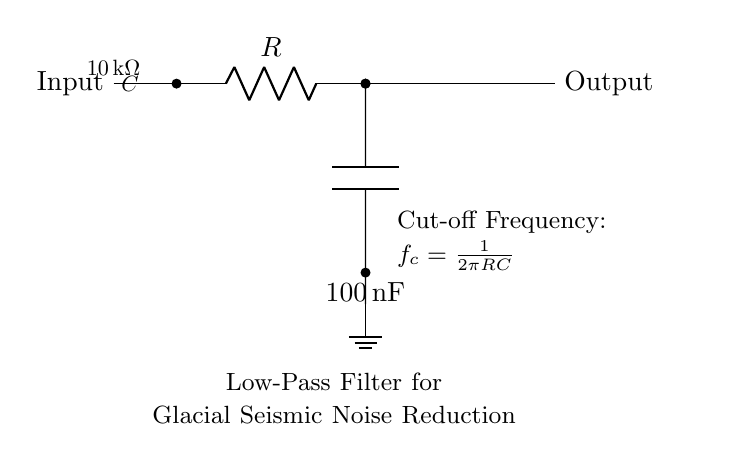What is the function of the circuit? The circuit is designed as a low-pass filter to reduce high-frequency noise in measurements. Its primary function is to allow the passage of low-frequency signals while attenuating higher-frequency signals.
Answer: Low-Pass Filter What is the resistance value used in the circuit? The circuit diagram shows a resistor labeled with a value of ten kilo-ohms, which indicates the resistance in the low-pass filter.
Answer: Ten kilo-ohms What is the capacitance value in the circuit? The capacitor in the circuit is labeled with a value of one hundred nano-farads, which specifies its capacitance.
Answer: One hundred nano-farads What is the cut-off frequency formula shown in the circuit? The cut-off frequency formula is provided in the circuit and is defined as the frequency at which the output power drops to half its maximum value, calculated using the provided resistance and capacitance values.
Answer: One over two pi RC How does changing the resistor value affect the cut-off frequency? Increasing the resistance would lower the cut-off frequency, allowing lower frequencies to pass while attenuating more of the higher frequencies. Conversely, decreasing the resistance increases the cut-off frequency. This relationship can be derived from the cut-off frequency formula.
Answer: Lower cut-off frequency What role does the capacitor play in this circuit? The capacitor works to store and release energy. In a low-pass filter, it allows low-frequency signals to pass while blocking high-frequency signals, essential for noise reduction in the seismic measurements.
Answer: Energy storage What type of circuit is represented in the diagram? The circuit is specifically a passive analog low-pass filter, which is characterized by its ability to filter frequency components without external power sources, relying only on passive components like resistors and capacitors.
Answer: Passive Analog Low-Pass Filter 